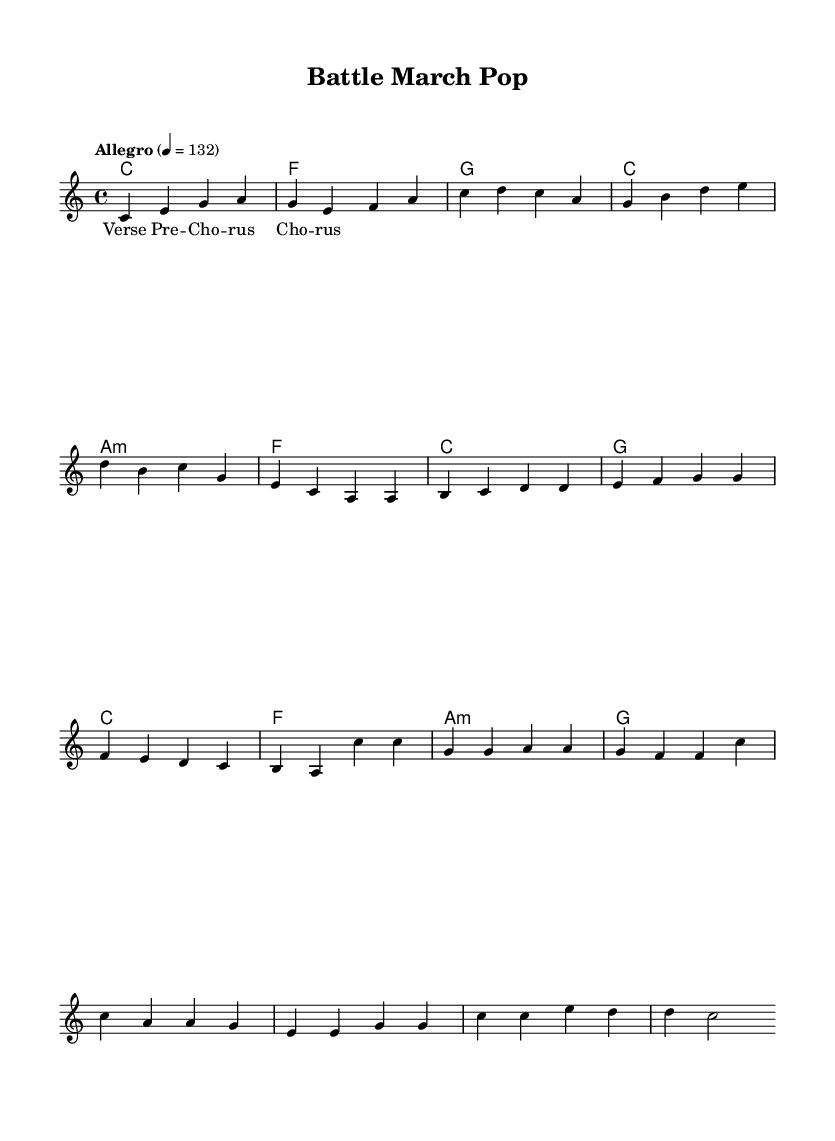What is the key signature of this music? The key signature is indicated at the beginning of the piece and shows no sharps or flats, which corresponds to C major.
Answer: C major What is the time signature? The time signature is displayed at the beginning of the sheet music, showing that there are four beats per measure, which is indicated by 4/4.
Answer: 4/4 What is the tempo marking for this piece? The tempo marking is written in the header and indicates a speed of "Allegro" at a specific beat of 132, which signifies a lively tempo.
Answer: Allegro How many measures are in the verse? By counting the measures underneath the verse section, there are four distinct measures listed.
Answer: 4 Which chord follows the pre-chorus? The chord progression in the pre-chorus ends with a G chord, which is evident in the harmonies section.
Answer: G What is the character of the music indicated in the title? The title "Battle March Pop" suggests a lively, upbeat style that can be associated with military-inspired rhythms.
Answer: Battle March Pop What type of musical form can be identified in this piece? The structure of the piece shows clear sections, including a verse, pre-chorus, and chorus, indicating a typical pop song form.
Answer: Verse-Pre-Chorus-Chorus 